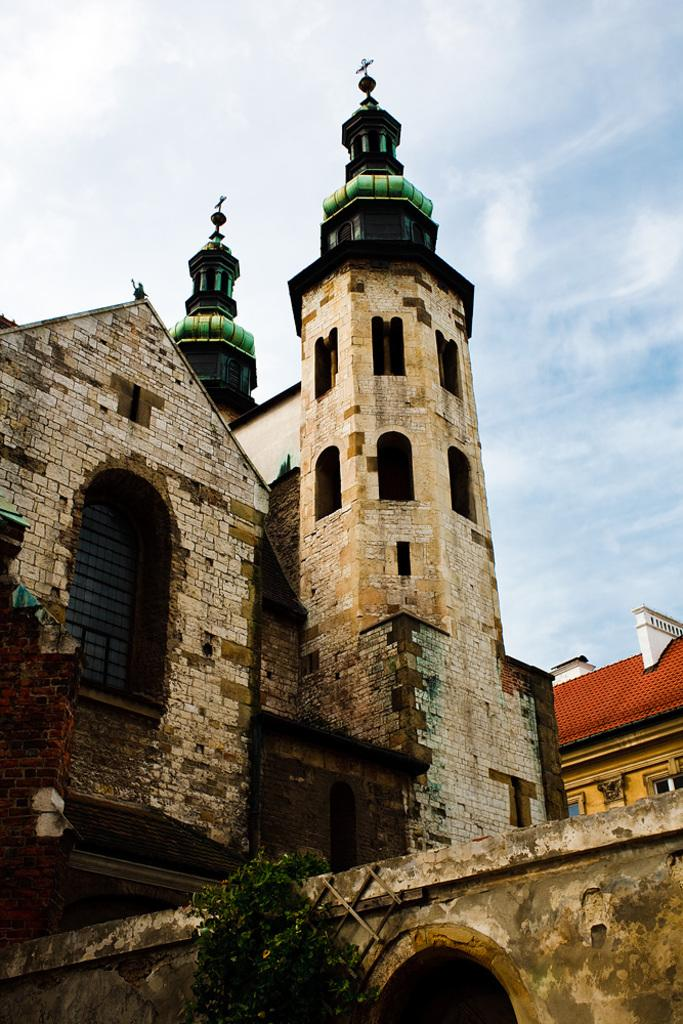What is the main subject in the center of the image? There are buildings in the center of the image. What can be seen at the top of the image? The sky is visible at the top of the image. What advice does the band give to the cup in the image? There is no band or cup present in the image, so no advice can be given. 